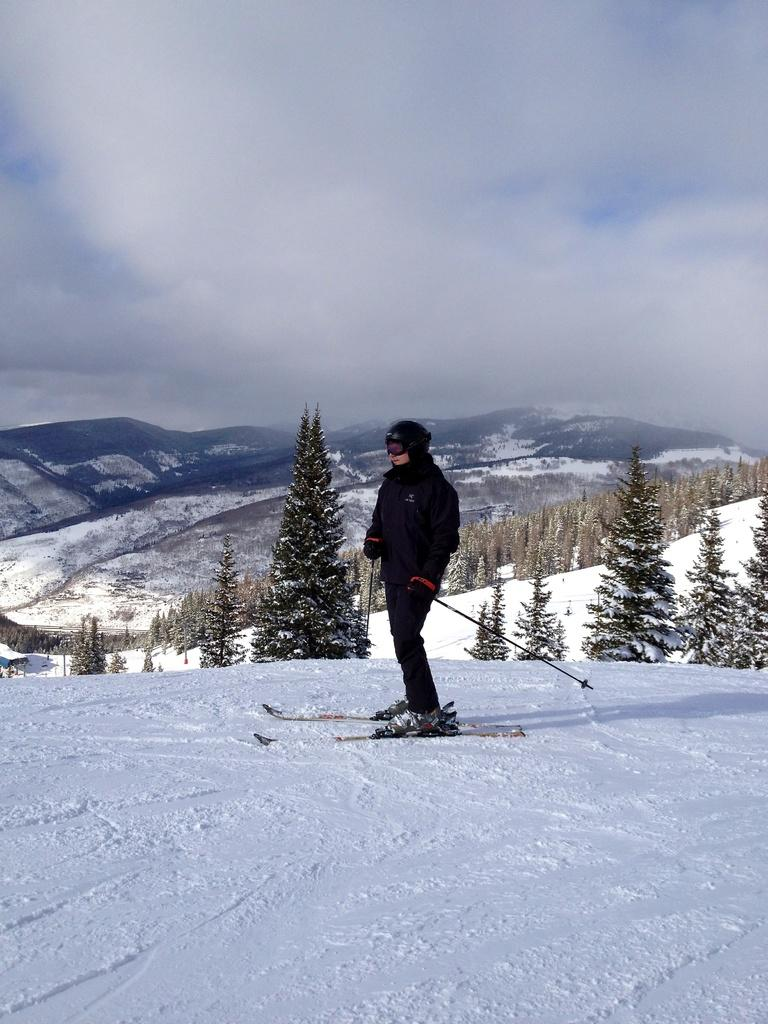What is the person in the image doing? The person is on ski-boards. What is the person holding in the image? The person is holding sticks, which are likely ski poles. What type of environment is visible in the image? There are trees, snow, mountains, and the sky visible in the image. What type of grain is being harvested by the person in the image? There is no grain present in the image; the person is on ski-boards and there is snow visible. What type of sweater is the person wearing in the image? The image does not provide enough detail to determine the type of sweater the person is wearing, if any. 